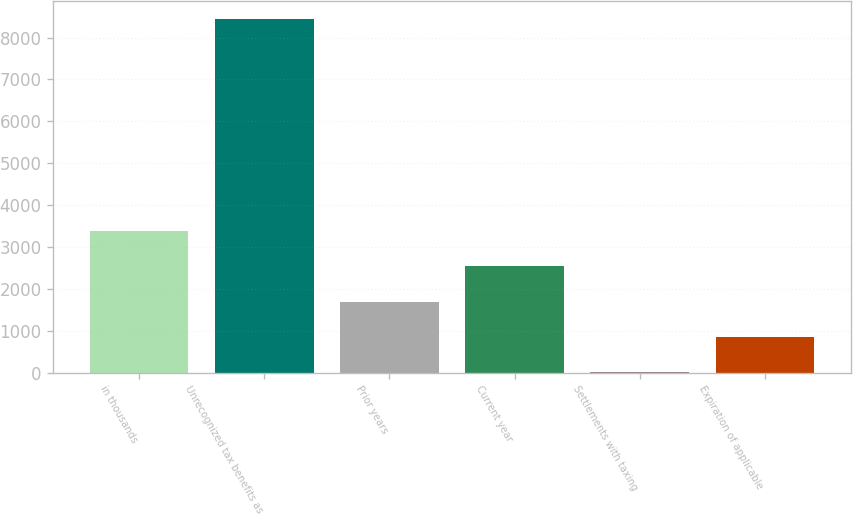Convert chart to OTSL. <chart><loc_0><loc_0><loc_500><loc_500><bar_chart><fcel>in thousands<fcel>Unrecognized tax benefits as<fcel>Prior years<fcel>Current year<fcel>Settlements with taxing<fcel>Expiration of applicable<nl><fcel>3381<fcel>8447<fcel>1692.32<fcel>2536.66<fcel>3.64<fcel>847.98<nl></chart> 